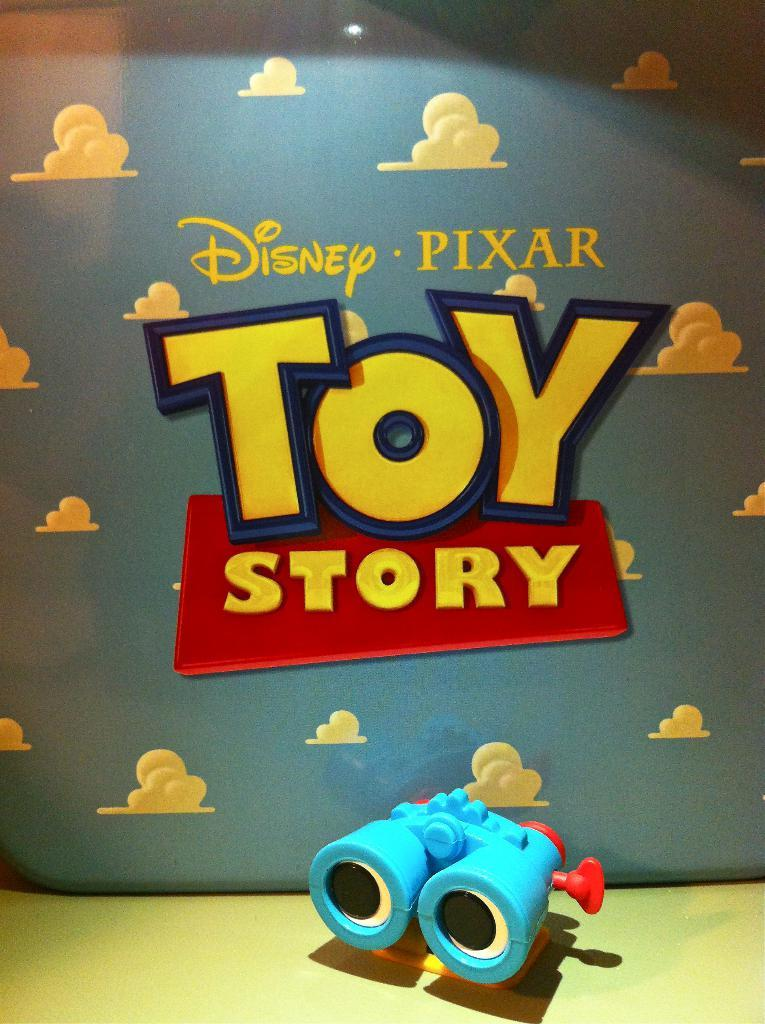What is on the floor in the image? There is a toy on the floor in the image. What is behind the toy? There is a wall behind the toy. What can be seen on the wall? The wall has some text on it and images of clouds. What type of bells can be heard ringing in the image? There are no bells present in the image, and therefore no sound can be heard. 